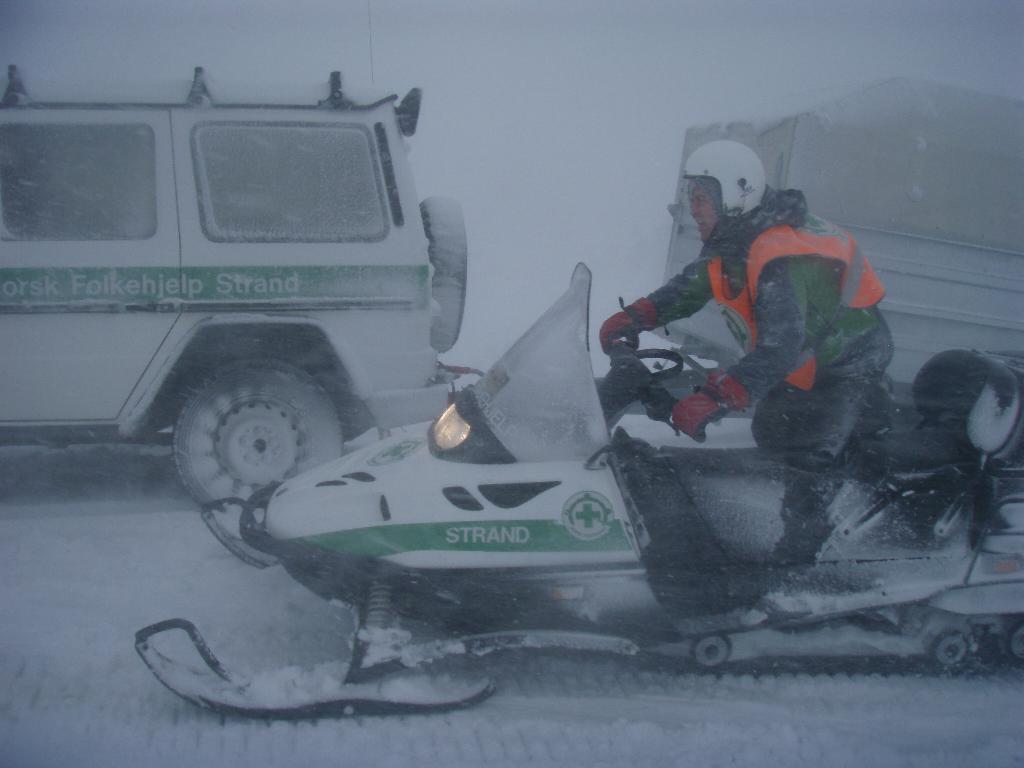Could you give a brief overview of what you see in this image? In this picture we can see a man is riding a snowmobile on the snow. Behind the man there are vehicles and the white background. 